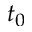<formula> <loc_0><loc_0><loc_500><loc_500>t _ { 0 }</formula> 